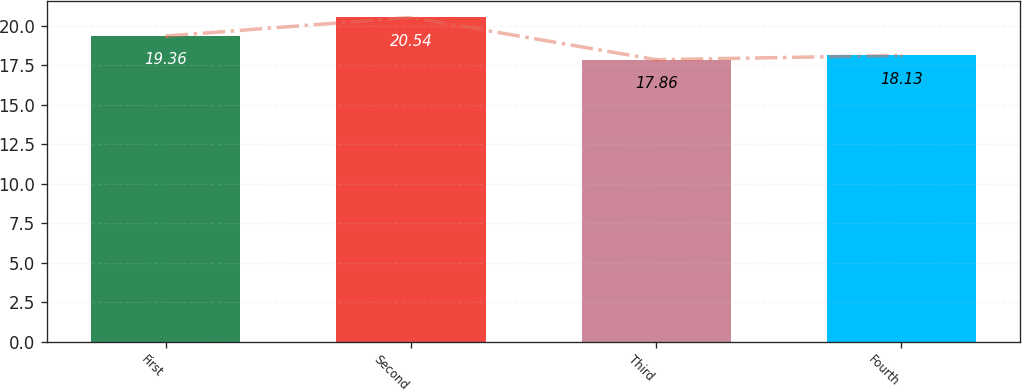<chart> <loc_0><loc_0><loc_500><loc_500><bar_chart><fcel>First<fcel>Second<fcel>Third<fcel>Fourth<nl><fcel>19.36<fcel>20.54<fcel>17.86<fcel>18.13<nl></chart> 